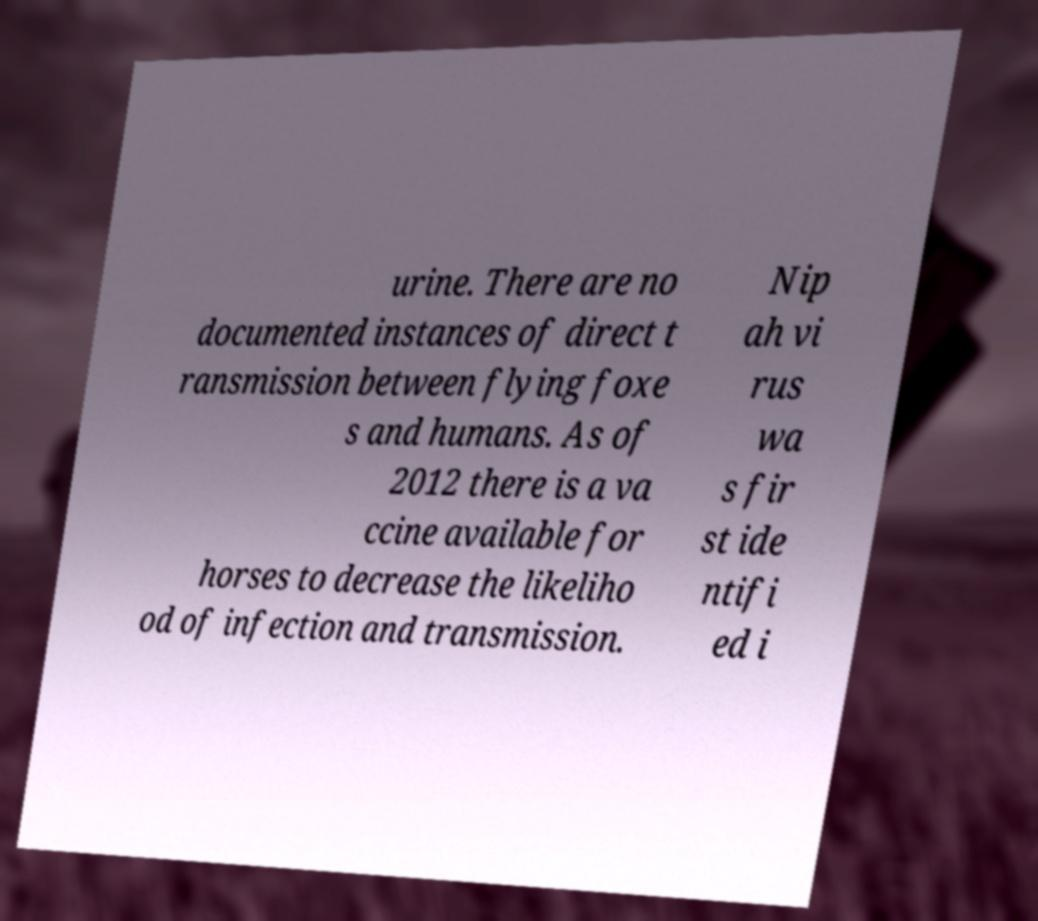Can you accurately transcribe the text from the provided image for me? urine. There are no documented instances of direct t ransmission between flying foxe s and humans. As of 2012 there is a va ccine available for horses to decrease the likeliho od of infection and transmission. Nip ah vi rus wa s fir st ide ntifi ed i 